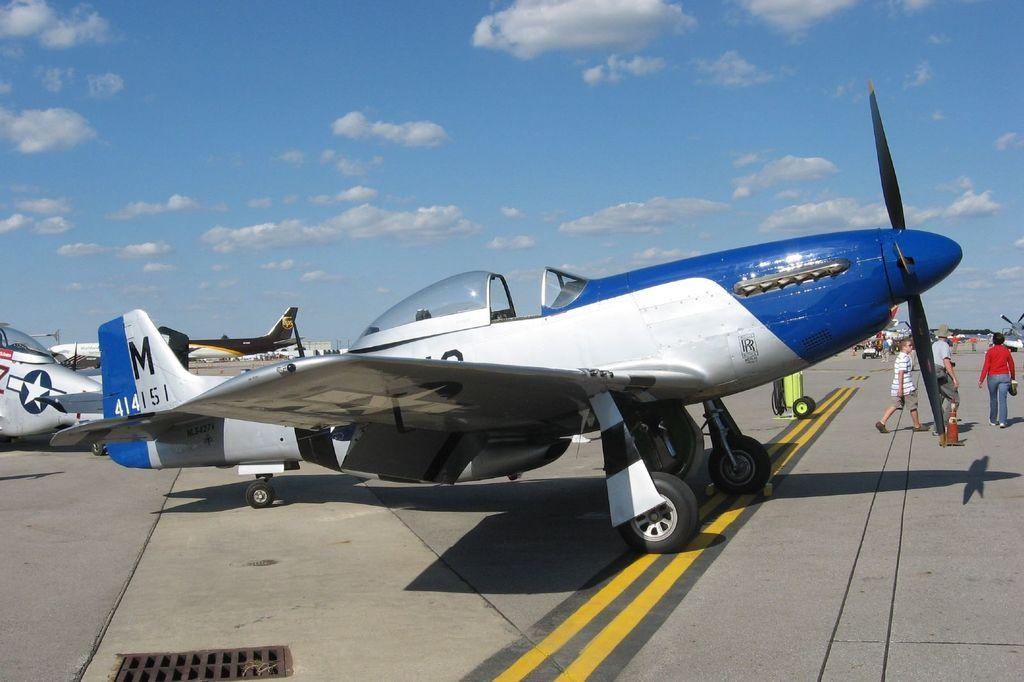<image>
Provide a brief description of the given image. A blue and white airplane has the numbers 414151 on the tail 